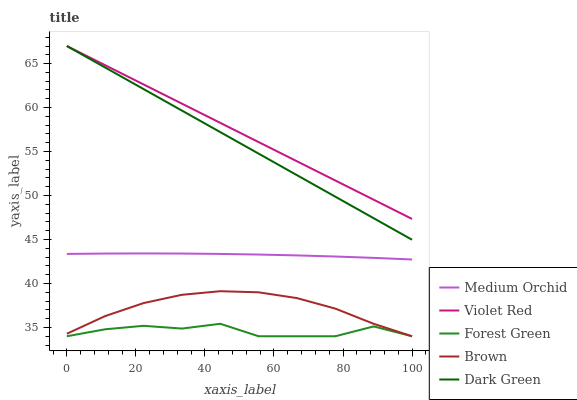Does Forest Green have the minimum area under the curve?
Answer yes or no. Yes. Does Violet Red have the maximum area under the curve?
Answer yes or no. Yes. Does Medium Orchid have the minimum area under the curve?
Answer yes or no. No. Does Medium Orchid have the maximum area under the curve?
Answer yes or no. No. Is Dark Green the smoothest?
Answer yes or no. Yes. Is Forest Green the roughest?
Answer yes or no. Yes. Is Violet Red the smoothest?
Answer yes or no. No. Is Violet Red the roughest?
Answer yes or no. No. Does Medium Orchid have the lowest value?
Answer yes or no. No. Does Dark Green have the highest value?
Answer yes or no. Yes. Does Medium Orchid have the highest value?
Answer yes or no. No. Is Brown less than Dark Green?
Answer yes or no. Yes. Is Violet Red greater than Forest Green?
Answer yes or no. Yes. Does Brown intersect Forest Green?
Answer yes or no. Yes. Is Brown less than Forest Green?
Answer yes or no. No. Is Brown greater than Forest Green?
Answer yes or no. No. Does Brown intersect Dark Green?
Answer yes or no. No. 